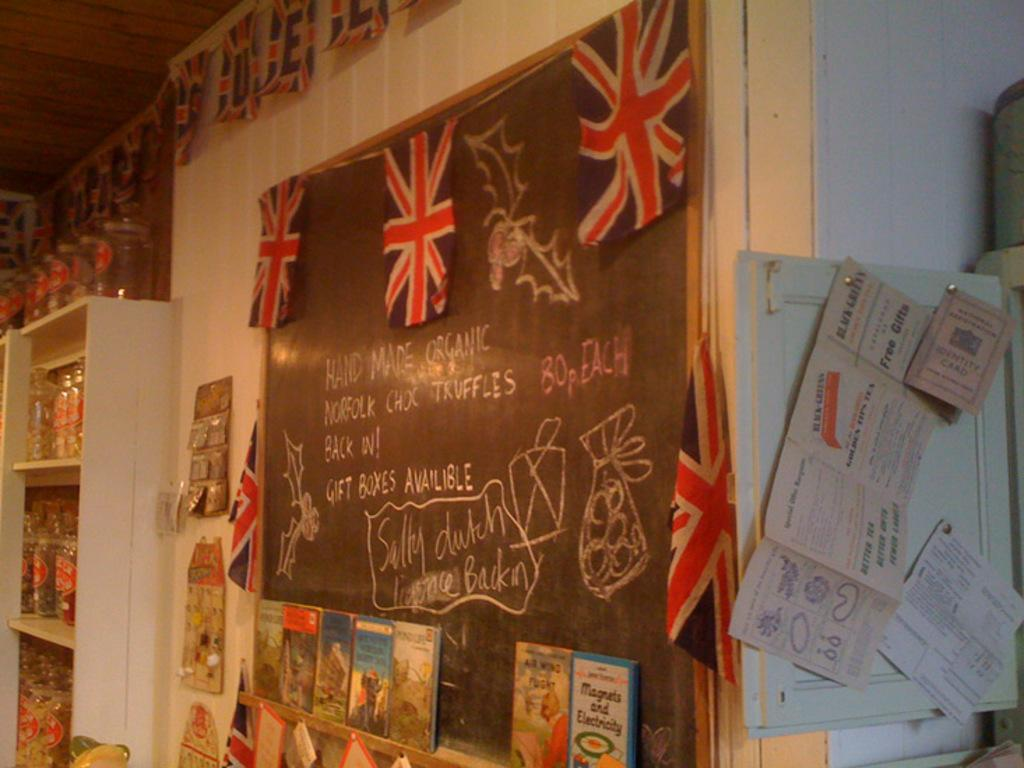<image>
Offer a succinct explanation of the picture presented. A chalkboard says that gift boxes are available. 